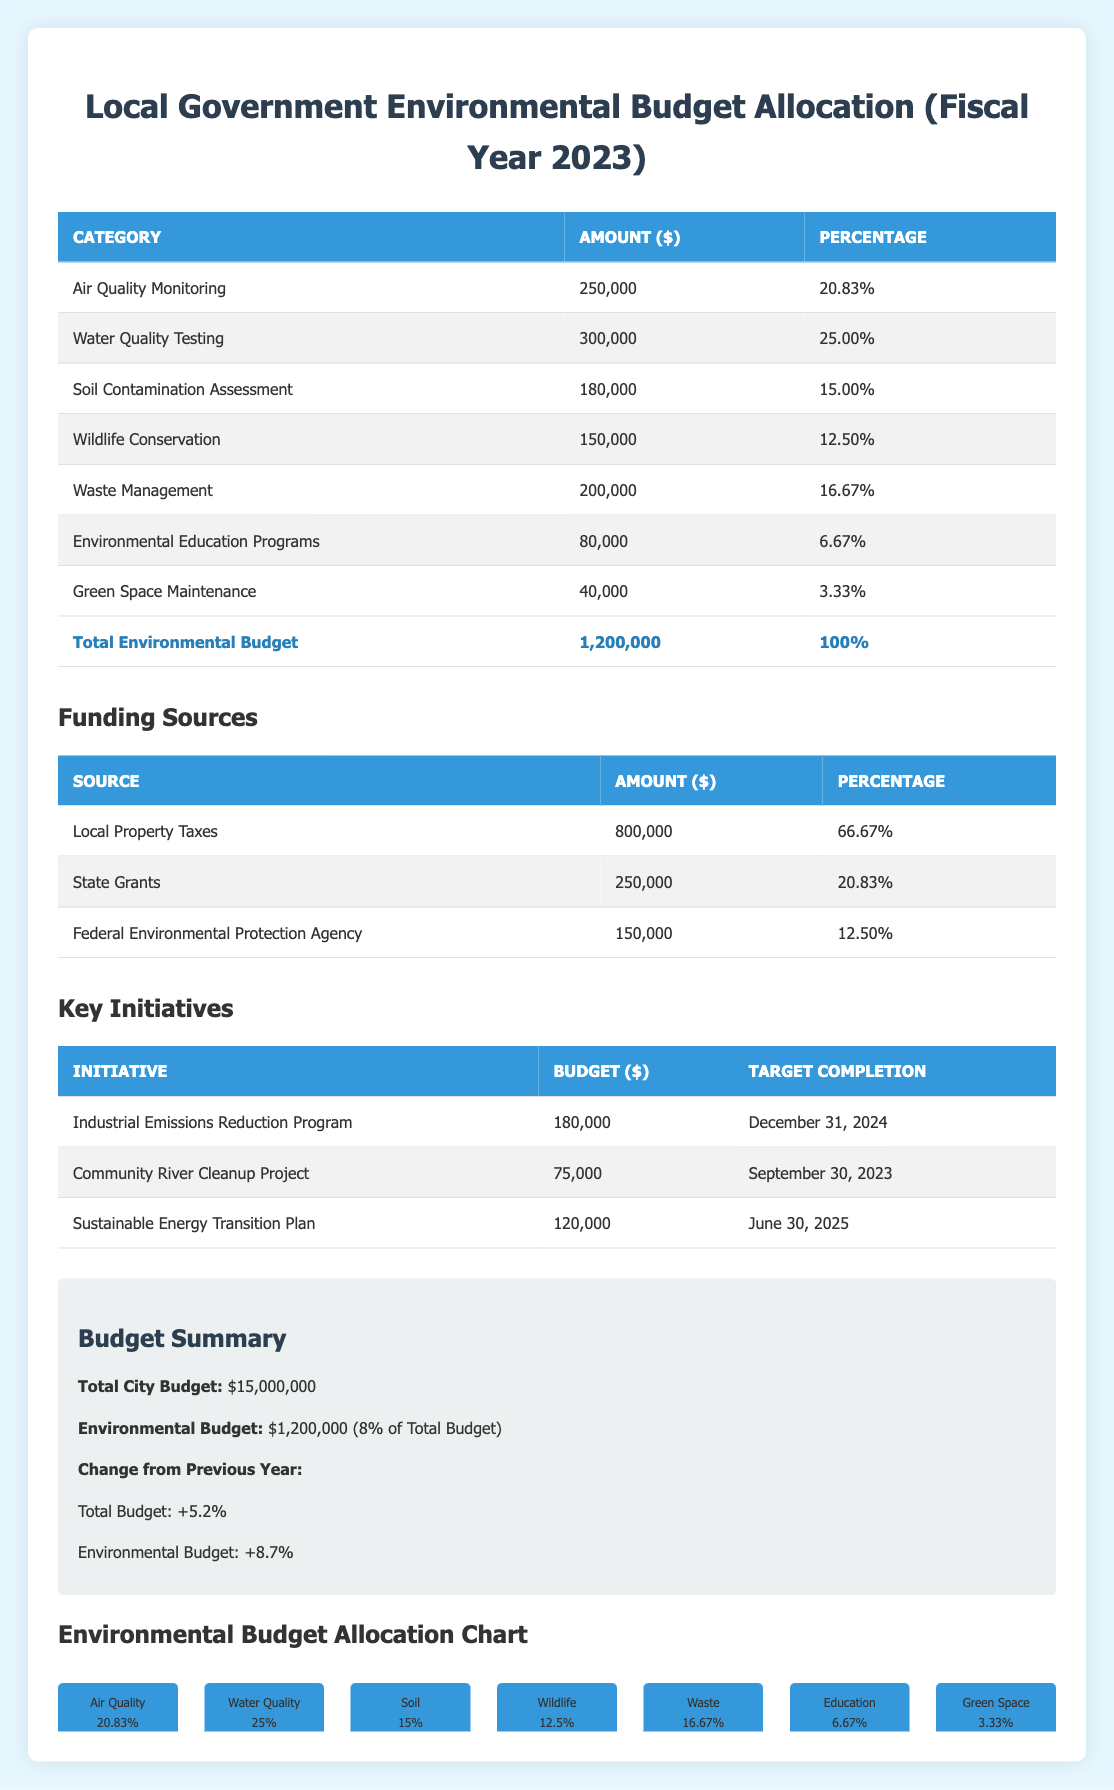What is the total environmental budget for 2023? The total environmental budget is explicitly stated in the summary section of the table as 1,200,000.
Answer: 1,200,000 How much funding comes from local property taxes? The funding source table indicates that local property taxes contribute 800,000, which is 66.67% of the total environmental budget.
Answer: 800,000 What percentage of the environmental budget is allocated to water quality testing? The table shows that water quality testing is allocated 300,000, which is 25% of the total environmental budget.
Answer: 25% Is the budget for environmental education programs greater than the budget for green space maintenance? Comparing the amounts, the budget for environmental education programs is 80,000, while for green space maintenance, it is 40,000. Thus, education programs receive more funding.
Answer: Yes What is the total budget for the key initiatives listed? To find the total budget for the initiatives: 180,000 + 75,000 + 120,000 = 375,000. Therefore, the total budget allocated to these initiatives is 375,000.
Answer: 375,000 What is the difference in the environmental budget change percentage from the previous year? The table states the environmental budget change from the previous year is 8.7%. There is no need for further calculation as it's a direct retrieval of data.
Answer: 8.7% What proportion of the total government budget is designated for environmental monitoring and protection? The total government budget is 15,000,000, and the environmental budget is 1,200,000. To find the proportion: (1,200,000 / 15,000,000) * 100 = 8%.
Answer: 8% Which category has the highest allocation in the environmental budget? From the allocations table, water quality testing has the highest allocation at 300,000, which is also 25% of the environmental budget.
Answer: Water Quality Testing What is the target completion date for the Community River Cleanup Project? The target completion date for the Community River Cleanup Project is provided directly in the key initiatives table as September 30, 2023.
Answer: September 30, 2023 